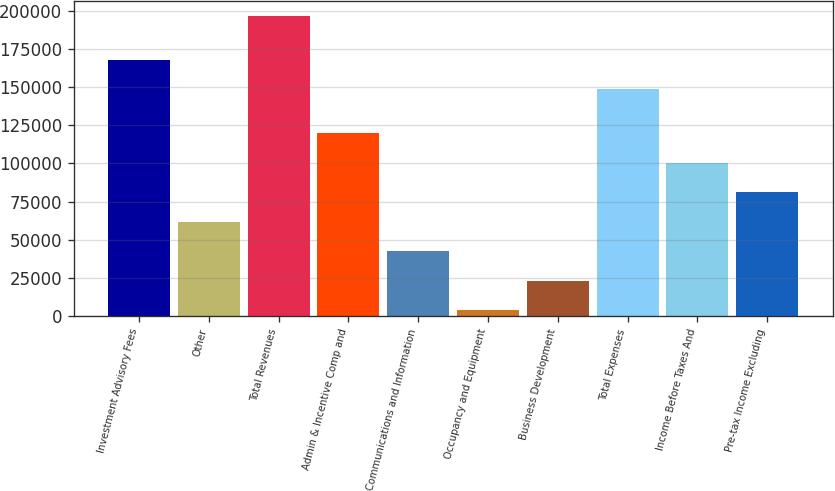Convert chart. <chart><loc_0><loc_0><loc_500><loc_500><bar_chart><fcel>Investment Advisory Fees<fcel>Other<fcel>Total Revenues<fcel>Admin & Incentive Comp and<fcel>Communications and Information<fcel>Occupancy and Equipment<fcel>Business Development<fcel>Total Expenses<fcel>Income Before Taxes And<fcel>Pre-tax Income Excluding<nl><fcel>168037<fcel>61777.9<fcel>196817<fcel>119652<fcel>42486.6<fcel>3904<fcel>23195.3<fcel>148746<fcel>100360<fcel>81069.2<nl></chart> 